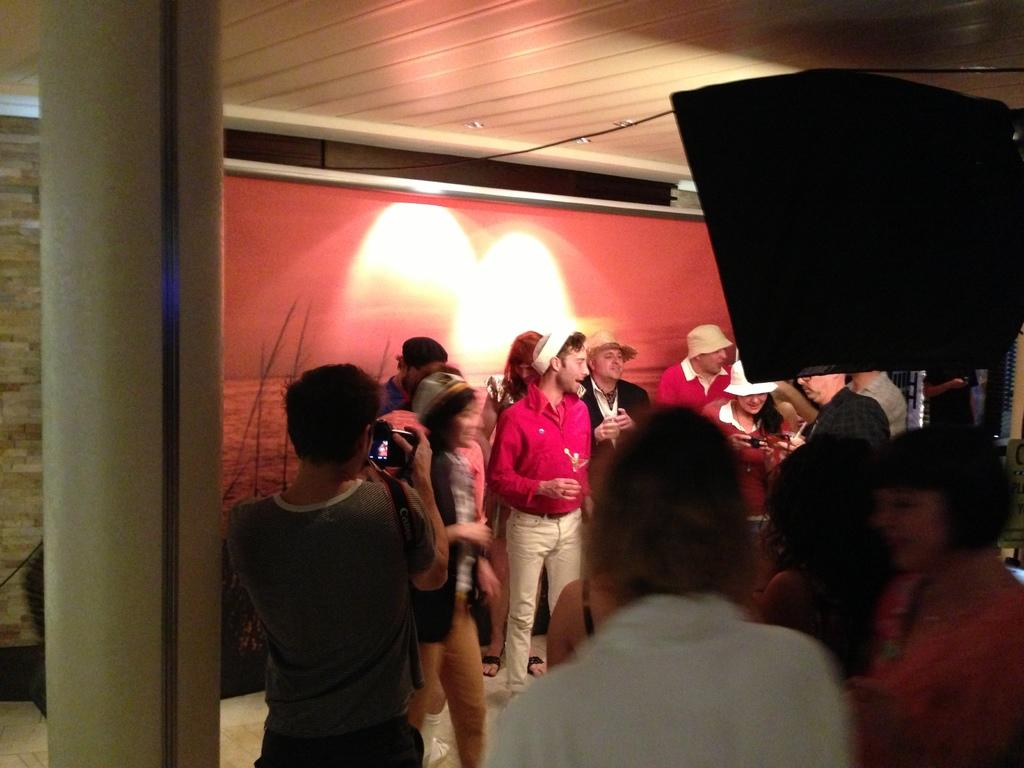How many people are in the image? There is a group of people in the image, but the exact number is not specified. What is one person in the group doing? One person is holding a camera. What architectural feature can be seen in the image? There is a pillar in the image. What is the object in the image? The object in the image is not described in detail, so we cannot identify it. What can be seen in the background of the image? There is a wall and a roof in the background of the image. What type of sound can be heard coming from the skin of the person holding the camera? There is no mention of any sounds or skin in the image, so we cannot answer this question. 